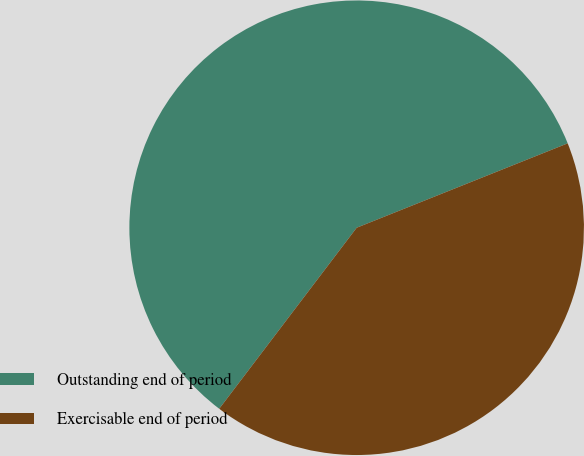Convert chart. <chart><loc_0><loc_0><loc_500><loc_500><pie_chart><fcel>Outstanding end of period<fcel>Exercisable end of period<nl><fcel>58.61%<fcel>41.39%<nl></chart> 